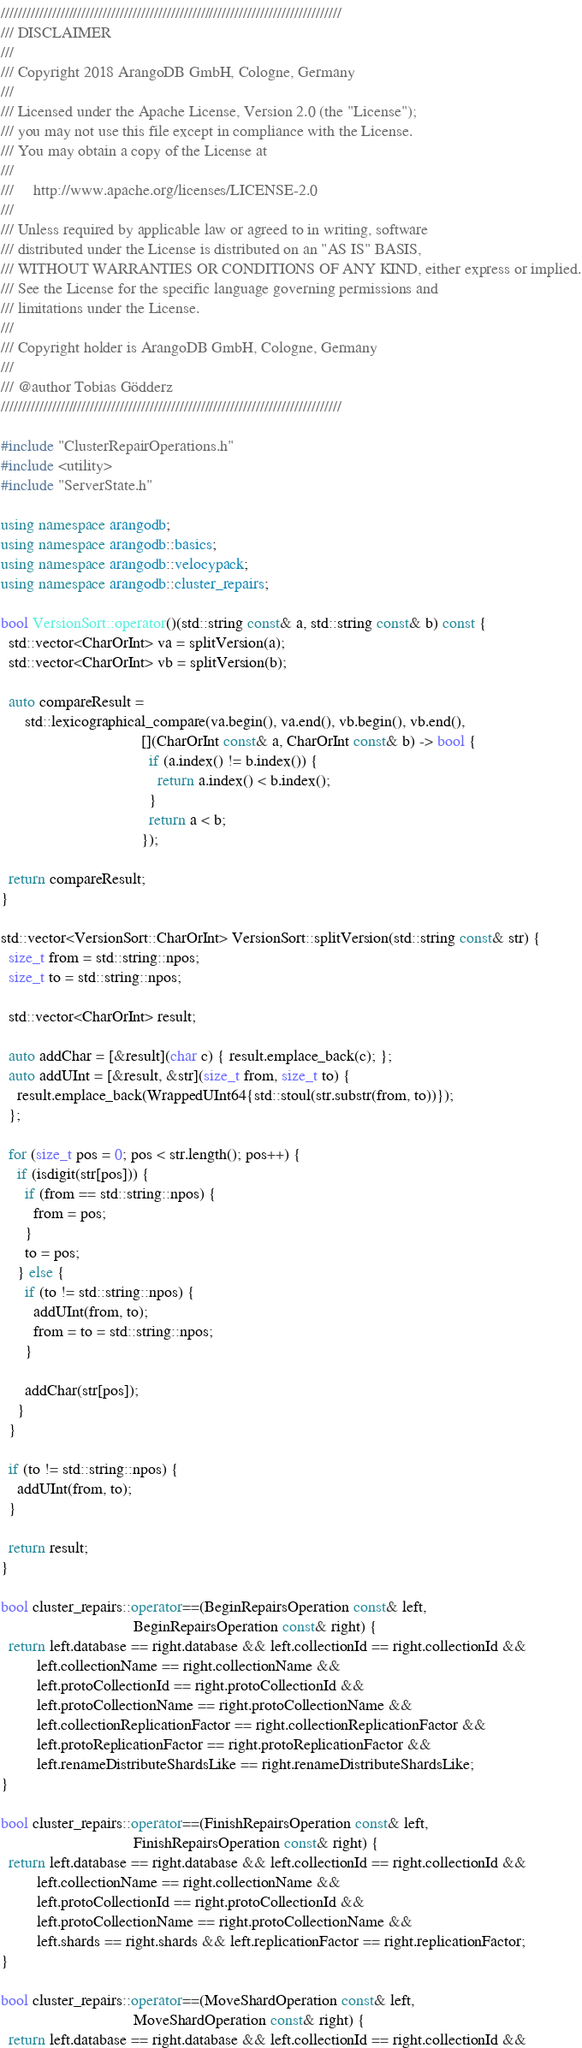<code> <loc_0><loc_0><loc_500><loc_500><_C++_>////////////////////////////////////////////////////////////////////////////////
/// DISCLAIMER
///
/// Copyright 2018 ArangoDB GmbH, Cologne, Germany
///
/// Licensed under the Apache License, Version 2.0 (the "License");
/// you may not use this file except in compliance with the License.
/// You may obtain a copy of the License at
///
///     http://www.apache.org/licenses/LICENSE-2.0
///
/// Unless required by applicable law or agreed to in writing, software
/// distributed under the License is distributed on an "AS IS" BASIS,
/// WITHOUT WARRANTIES OR CONDITIONS OF ANY KIND, either express or implied.
/// See the License for the specific language governing permissions and
/// limitations under the License.
///
/// Copyright holder is ArangoDB GmbH, Cologne, Germany
///
/// @author Tobias Gödderz
////////////////////////////////////////////////////////////////////////////////

#include "ClusterRepairOperations.h"
#include <utility>
#include "ServerState.h"

using namespace arangodb;
using namespace arangodb::basics;
using namespace arangodb::velocypack;
using namespace arangodb::cluster_repairs;

bool VersionSort::operator()(std::string const& a, std::string const& b) const {
  std::vector<CharOrInt> va = splitVersion(a);
  std::vector<CharOrInt> vb = splitVersion(b);

  auto compareResult =
      std::lexicographical_compare(va.begin(), va.end(), vb.begin(), vb.end(),
                                   [](CharOrInt const& a, CharOrInt const& b) -> bool {
                                     if (a.index() != b.index()) {
                                       return a.index() < b.index();
                                     }
                                     return a < b;
                                   });

  return compareResult;
}

std::vector<VersionSort::CharOrInt> VersionSort::splitVersion(std::string const& str) {
  size_t from = std::string::npos;
  size_t to = std::string::npos;

  std::vector<CharOrInt> result;

  auto addChar = [&result](char c) { result.emplace_back(c); };
  auto addUInt = [&result, &str](size_t from, size_t to) {
    result.emplace_back(WrappedUInt64{std::stoul(str.substr(from, to))});
  };

  for (size_t pos = 0; pos < str.length(); pos++) {
    if (isdigit(str[pos])) {
      if (from == std::string::npos) {
        from = pos;
      }
      to = pos;
    } else {
      if (to != std::string::npos) {
        addUInt(from, to);
        from = to = std::string::npos;
      }

      addChar(str[pos]);
    }
  }

  if (to != std::string::npos) {
    addUInt(from, to);
  }

  return result;
}

bool cluster_repairs::operator==(BeginRepairsOperation const& left,
                                 BeginRepairsOperation const& right) {
  return left.database == right.database && left.collectionId == right.collectionId &&
         left.collectionName == right.collectionName &&
         left.protoCollectionId == right.protoCollectionId &&
         left.protoCollectionName == right.protoCollectionName &&
         left.collectionReplicationFactor == right.collectionReplicationFactor &&
         left.protoReplicationFactor == right.protoReplicationFactor &&
         left.renameDistributeShardsLike == right.renameDistributeShardsLike;
}

bool cluster_repairs::operator==(FinishRepairsOperation const& left,
                                 FinishRepairsOperation const& right) {
  return left.database == right.database && left.collectionId == right.collectionId &&
         left.collectionName == right.collectionName &&
         left.protoCollectionId == right.protoCollectionId &&
         left.protoCollectionName == right.protoCollectionName &&
         left.shards == right.shards && left.replicationFactor == right.replicationFactor;
}

bool cluster_repairs::operator==(MoveShardOperation const& left,
                                 MoveShardOperation const& right) {
  return left.database == right.database && left.collectionId == right.collectionId &&</code> 